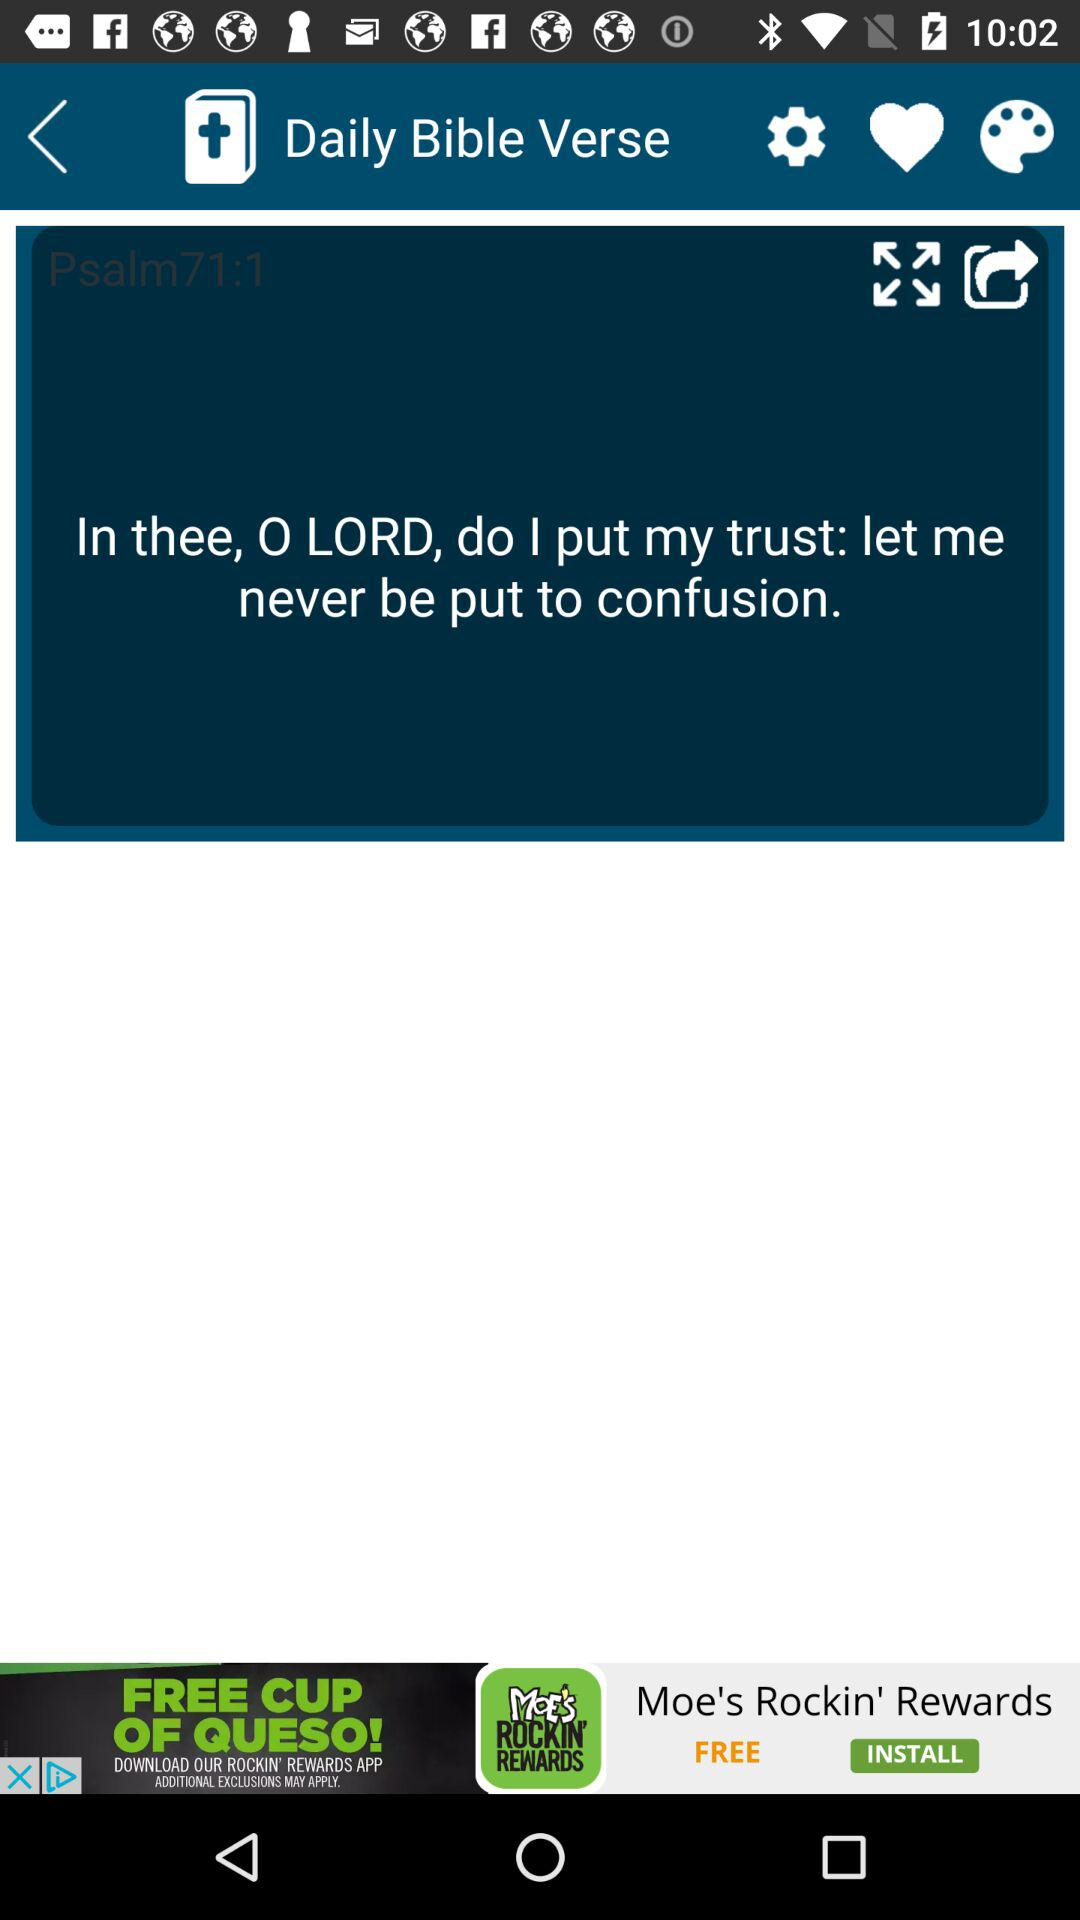What is the name of the application? The name of the application is "Daily Bible Verse". 